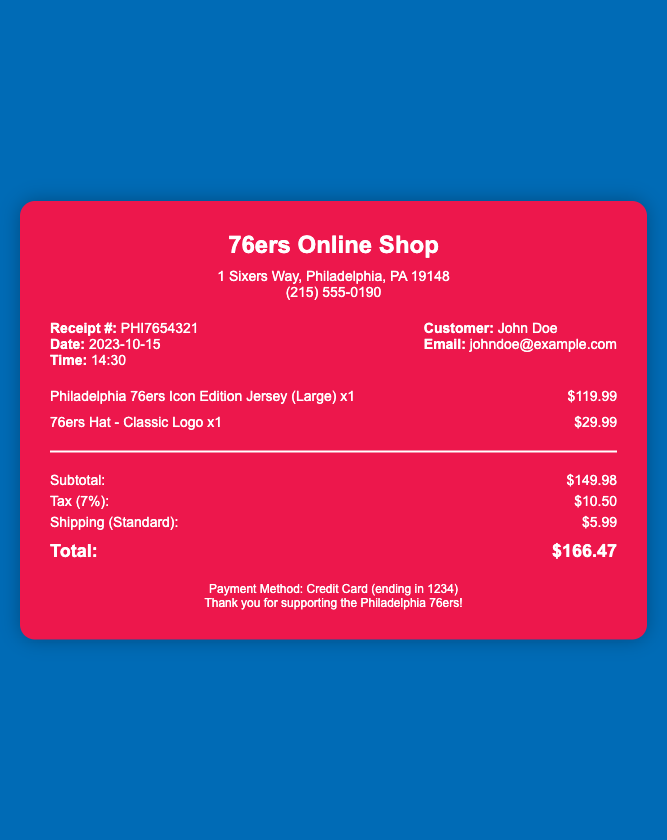What is the receipt number? The receipt number is listed under the receipt details section of the document.
Answer: PHI7654321 What is the date of the purchase? The date the transaction took place is clearly mentioned in the receipt details.
Answer: 2023-10-15 What is the subtotal amount? The subtotal is the sum of the itemized prices before tax and shipping, found in the totals section.
Answer: $149.98 What is the tax percentage applied? The tax percentage is stated in the totals section; it represents the sales tax applied to the subtotal.
Answer: 7% What items were purchased? The items purchased are listed individually in the items section of the receipt.
Answer: Philadelphia 76ers Icon Edition Jersey (Large), 76ers Hat - Classic Logo What is the total amount after tax and shipping? The total is calculated by adding the subtotal, tax, and shipping costs, summarized in the totals section.
Answer: $166.47 What was the shipping cost? The cost for shipping is explicitly mentioned in the totals section of the document.
Answer: $5.99 Who is the customer? The customer's name is provided in the receipt details section of the document.
Answer: John Doe What payment method was used? The payment method is mentioned in the footer of the document.
Answer: Credit Card (ending in 1234) 